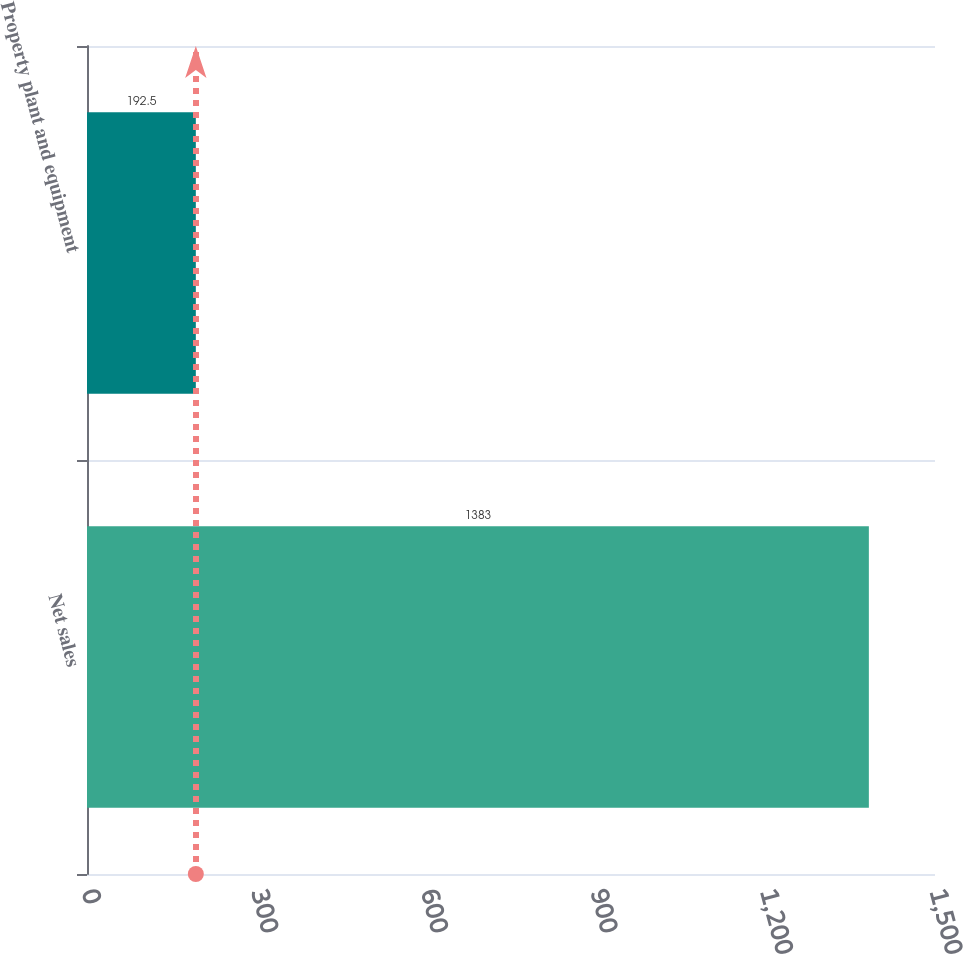<chart> <loc_0><loc_0><loc_500><loc_500><bar_chart><fcel>Net sales<fcel>Property plant and equipment<nl><fcel>1383<fcel>192.5<nl></chart> 